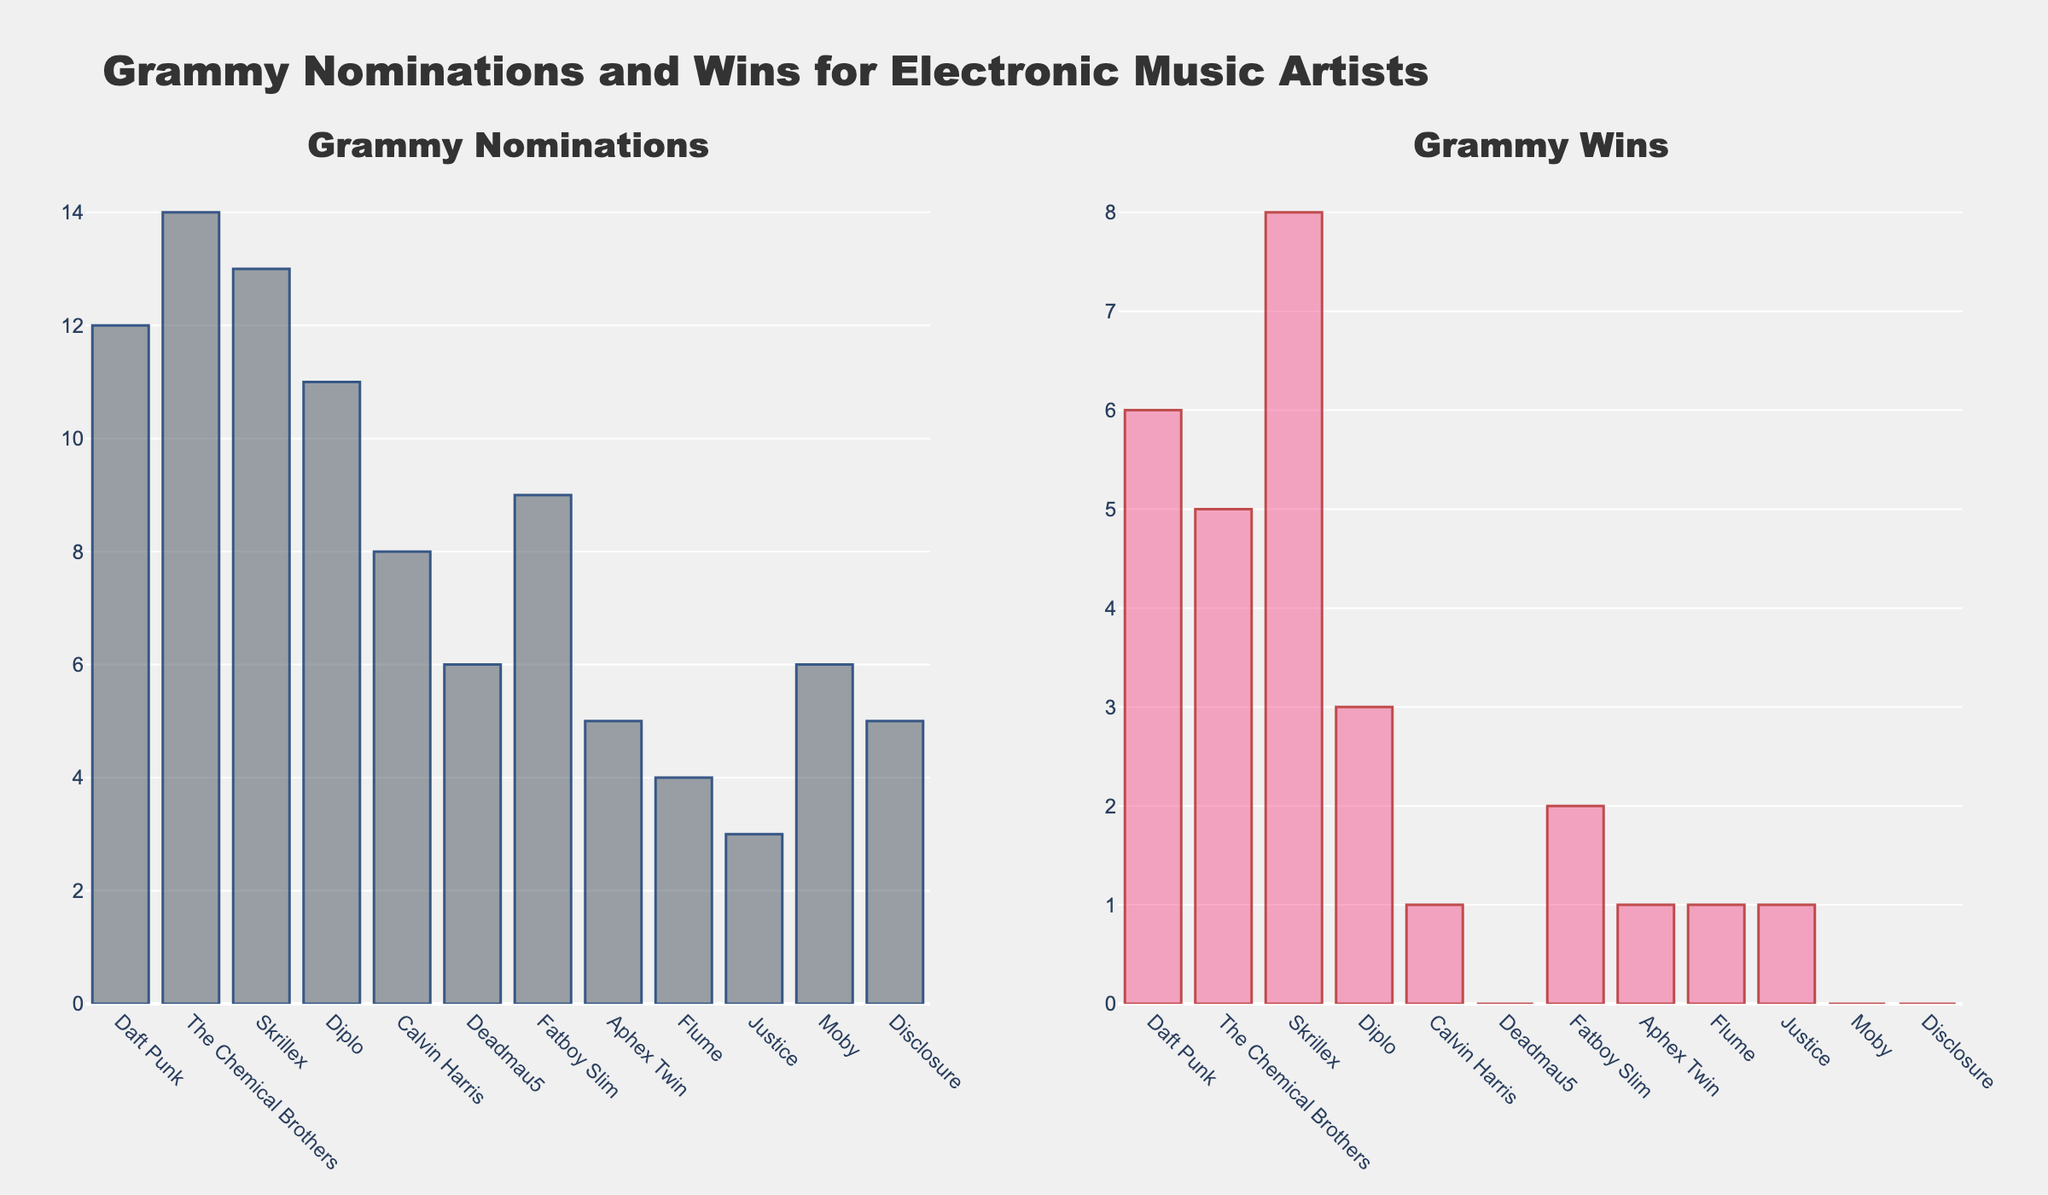Which artist has the most Grammy nominations? From the bar chart in the "Grammy Nominations" subplot, the tallest bar corresponds to The Chemical Brothers, indicating they have the most nominations.
Answer: The Chemical Brothers Who has more Grammy wins, Daft Punk or Skrillex? In the "Grammy Wins" subplot, the bar for Skrillex is taller than the bar for Daft Punk, indicating Skrillex has more wins.
Answer: Skrillex What is the difference in Grammy wins between Daft Punk and Deadmau5? In the "Grammy Wins" subplot, Daft Punk has a bar height of 6 wins and Deadmau5 has a bar height of 0 wins. The difference is 6 - 0.
Answer: 6 Which artist has the fewest Grammy wins among the listed artists? In the "Grammy Wins" subplot, several artists (Deadmau5, Moby, Disclosure) have bars the same height of 0 wins, indicating they have the fewest wins.
Answer: Deadmau5, Moby, Disclosure Compare the number of Grammy nominations of Diplo and Calvin Harris. Who has more, and by how much? In the "Grammy Nominations" subplot, Diplo has a bar height of 11 nominations and Calvin Harris has a bar height of 8 nominations. The difference is 11 - 8.
Answer: Diplo, by 3 What is the average number of Grammy wins for Daft Punk, The Chemical Brothers, and Skrillex? Daft Punk has 6 wins, The Chemical Brothers have 5 wins, and Skrillex has 8 wins. The average is calculated as (6 + 5 + 8) / 3 = 19 / 3.
Answer: 6.33 Which color represents Grammy nominations in the bar chart? In the chart, the bars for Grammy nominations are colored in a shade of blue.
Answer: Blue How many artists have exactly 1 Grammy win according to the plot? Observing the "Grammy Wins" subplot, Calvin Harris, Aphex Twin, Flume, and Justice each have bars representing 1 win. Count the number of such bars.
Answer: 4 What is the combined total of Grammy nominations for The Chemical Brothers and Skrillex? The Chemical Brothers have 14 nominations and Skrillex has 13 nominations. The combined total is 14 + 13.
Answer: 27 Does Daft Punk have more wins than nominations? Referring to the subplot for nominations and wins, Daft Punk has 12 nominations and 6 wins. Clearly, nominations are more.
Answer: No 